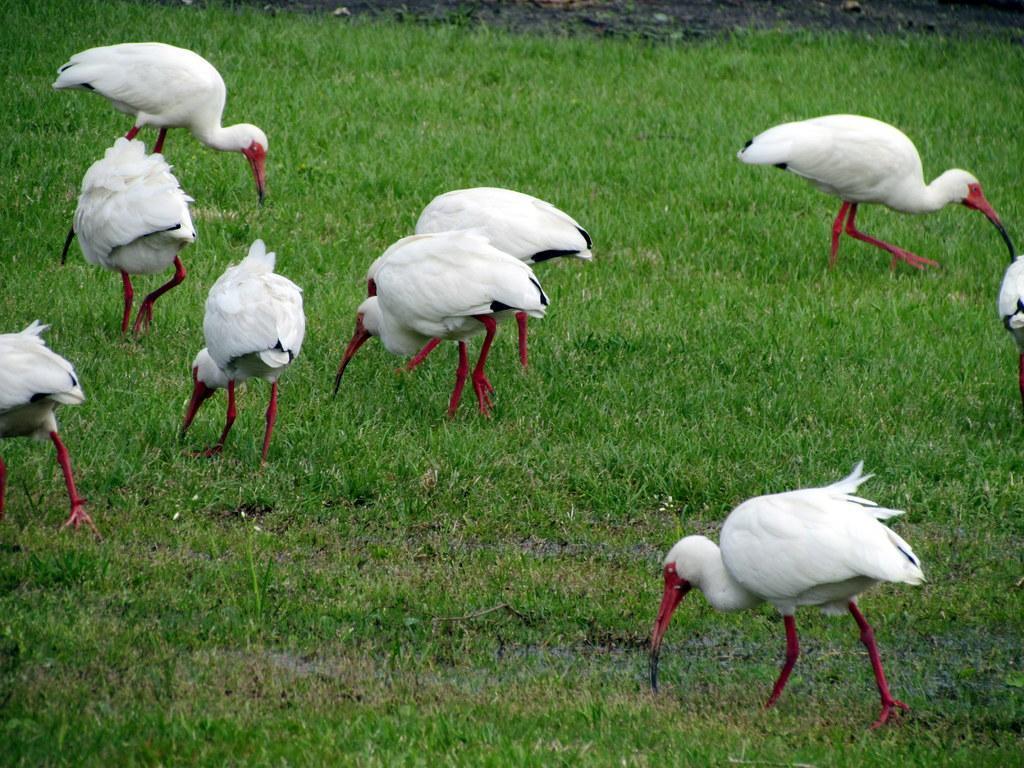How would you summarize this image in a sentence or two? This picture consists of birds visible on grass. 